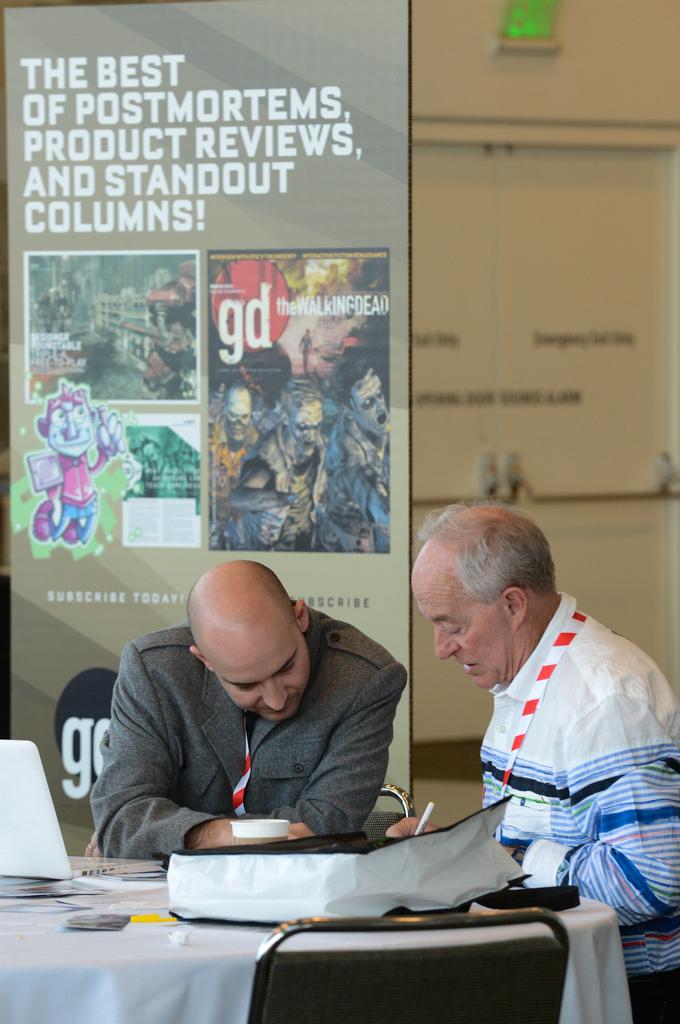What kind of reviews does this magazine do?
Provide a succinct answer. Product. What two initials are on the back wall?
Your response must be concise. Gd. 